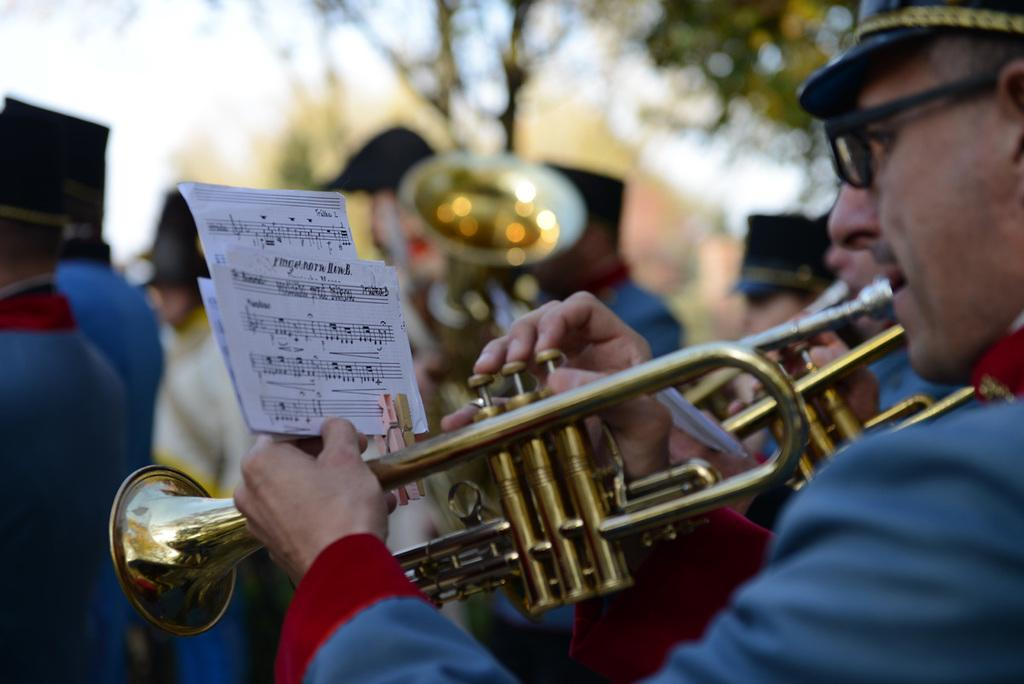How many people are in the image? There are many people in the image. What are the people wearing? The people are wearing the same costume. What are the people doing in the image? The people are playing trumpets. What symbols can be seen in front of the people? There are music notes in front of the people. What can be seen in the background of the image? There are trees in the background of the image. What type of scissors are being used to cut the trees in the background? There are no scissors present in the image, and the trees are not being cut. 